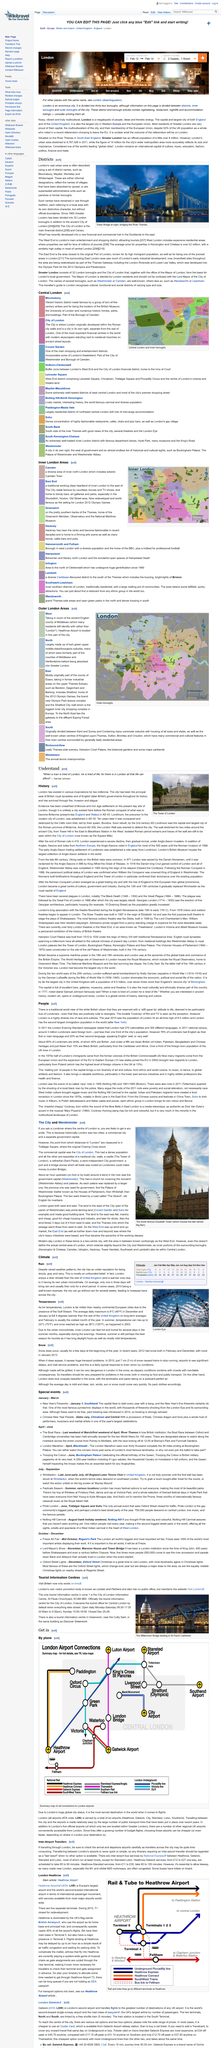Give some essential details in this illustration. There are 32 boroughs in London. The financial district in London is located in the City of London. The above picture represents the central area of London and its inner boroughs. The photo was taken at Tower Bridge in London at night, revealing the beautiful lit-up architecture of the bridge against the dark sky. Covent Garden is a significant shopping and entertainment hub in Central London, renowned for its vibrant atmosphere, diverse range of retail outlets, and numerous cultural attractions. 